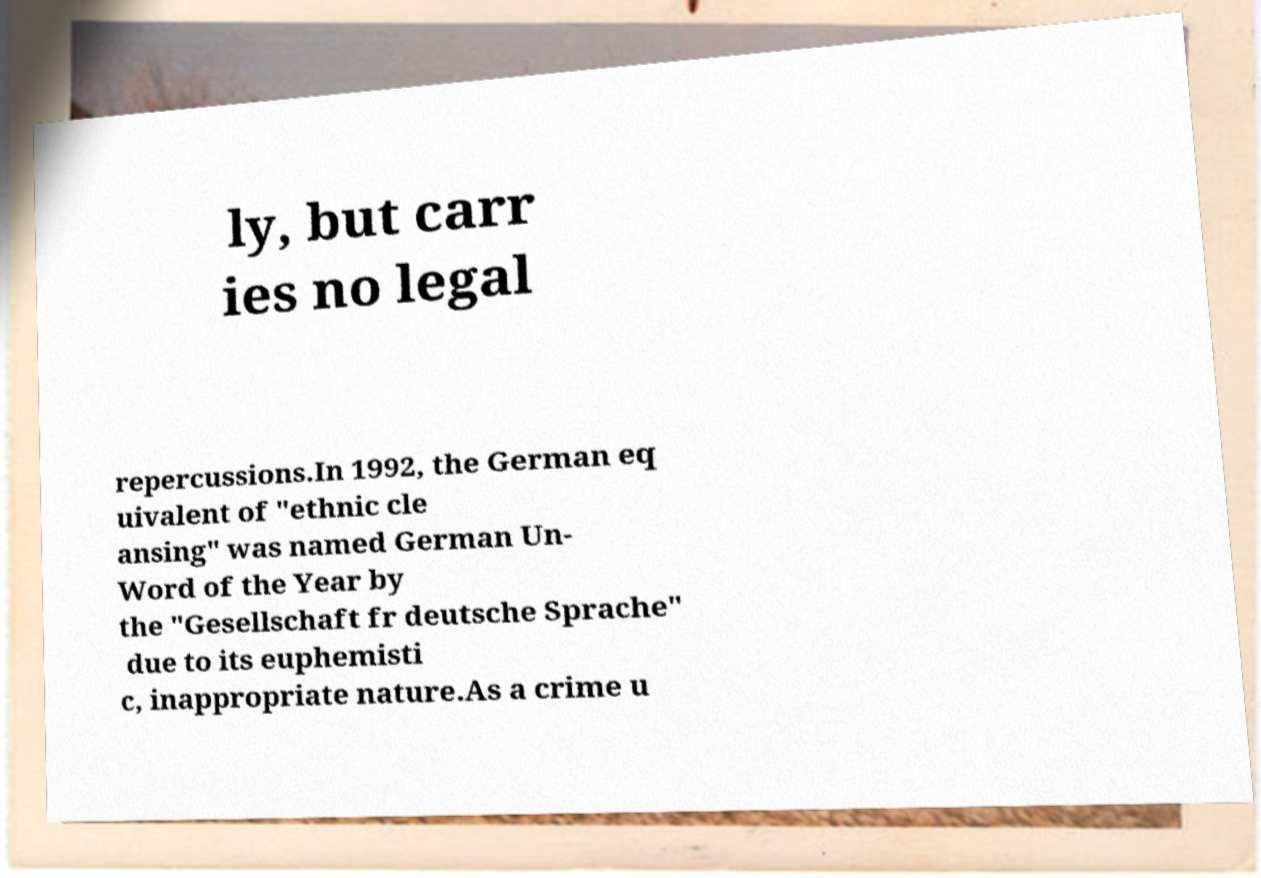Could you assist in decoding the text presented in this image and type it out clearly? ly, but carr ies no legal repercussions.In 1992, the German eq uivalent of "ethnic cle ansing" was named German Un- Word of the Year by the "Gesellschaft fr deutsche Sprache" due to its euphemisti c, inappropriate nature.As a crime u 